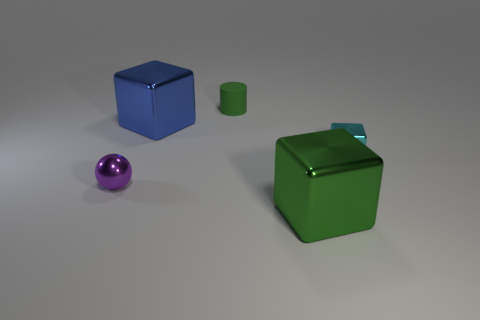Add 5 small cyan metallic cylinders. How many objects exist? 10 Subtract all cylinders. How many objects are left? 4 Subtract 0 blue balls. How many objects are left? 5 Subtract all cyan metallic blocks. Subtract all matte cylinders. How many objects are left? 3 Add 4 green objects. How many green objects are left? 6 Add 5 large shiny cylinders. How many large shiny cylinders exist? 5 